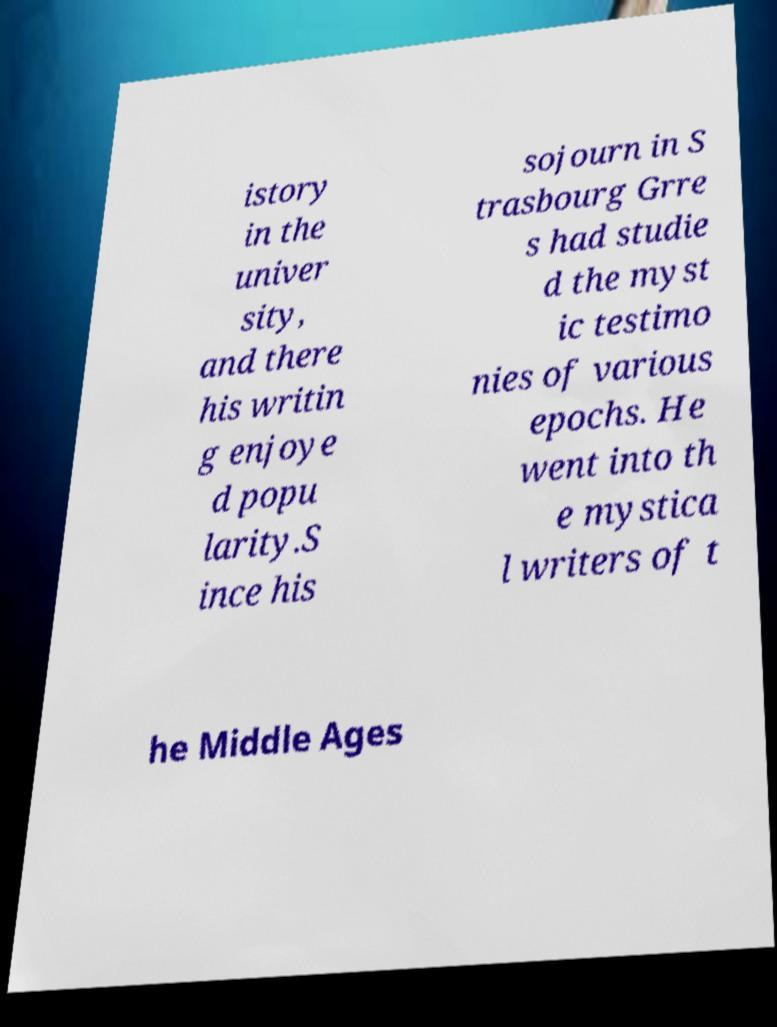For documentation purposes, I need the text within this image transcribed. Could you provide that? istory in the univer sity, and there his writin g enjoye d popu larity.S ince his sojourn in S trasbourg Grre s had studie d the myst ic testimo nies of various epochs. He went into th e mystica l writers of t he Middle Ages 